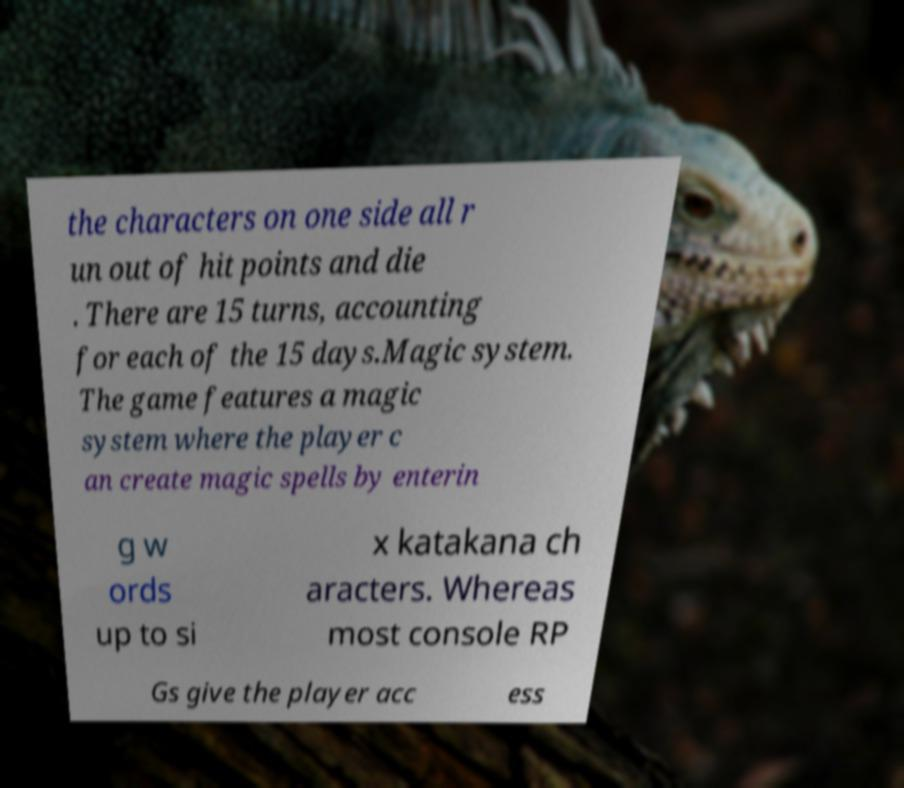Please read and relay the text visible in this image. What does it say? the characters on one side all r un out of hit points and die . There are 15 turns, accounting for each of the 15 days.Magic system. The game features a magic system where the player c an create magic spells by enterin g w ords up to si x katakana ch aracters. Whereas most console RP Gs give the player acc ess 